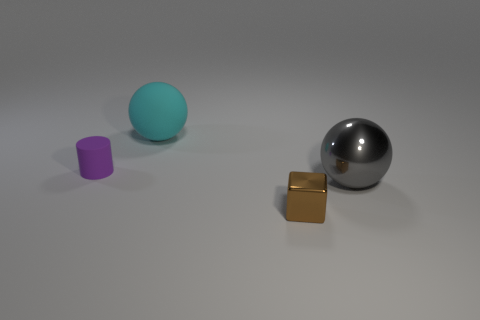Add 2 tiny brown balls. How many objects exist? 6 Subtract all cubes. How many objects are left? 3 Subtract all tiny red metallic blocks. Subtract all tiny cylinders. How many objects are left? 3 Add 2 small purple rubber things. How many small purple rubber things are left? 3 Add 1 blue rubber spheres. How many blue rubber spheres exist? 1 Subtract 0 blue cylinders. How many objects are left? 4 